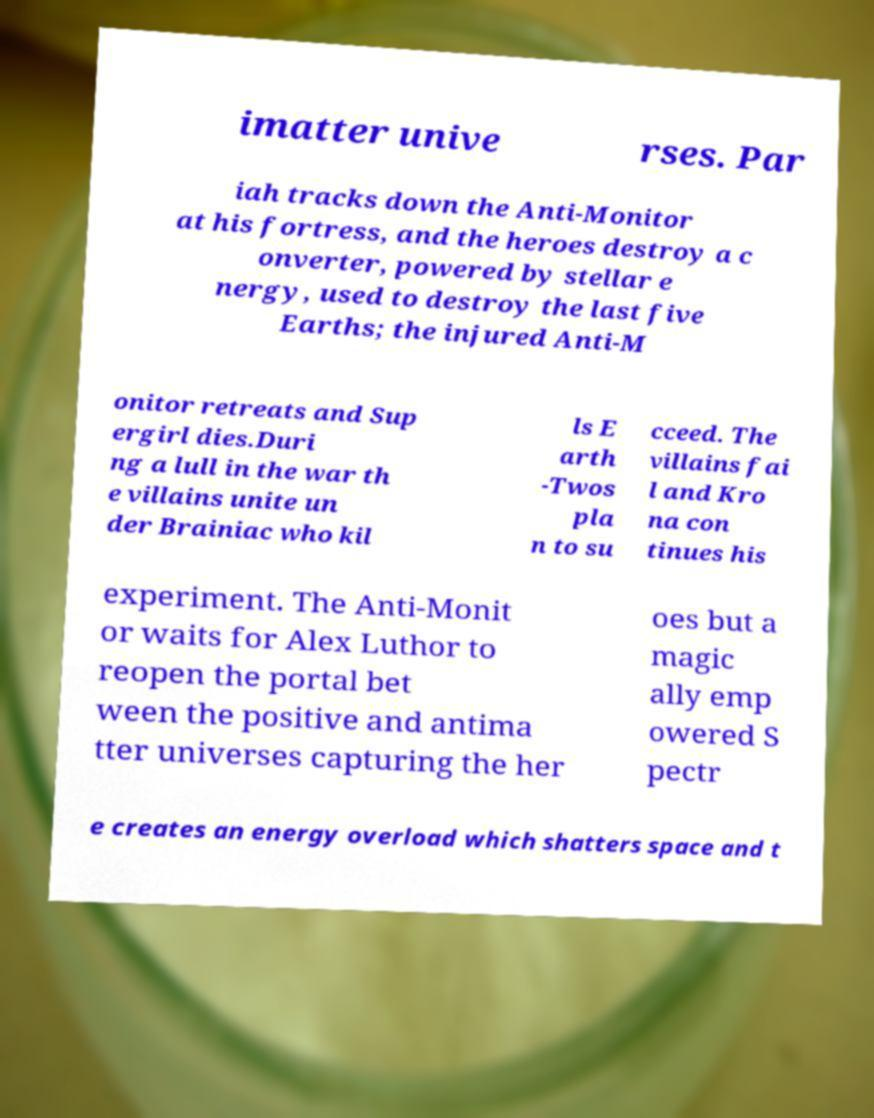Please identify and transcribe the text found in this image. imatter unive rses. Par iah tracks down the Anti-Monitor at his fortress, and the heroes destroy a c onverter, powered by stellar e nergy, used to destroy the last five Earths; the injured Anti-M onitor retreats and Sup ergirl dies.Duri ng a lull in the war th e villains unite un der Brainiac who kil ls E arth -Twos pla n to su cceed. The villains fai l and Kro na con tinues his experiment. The Anti-Monit or waits for Alex Luthor to reopen the portal bet ween the positive and antima tter universes capturing the her oes but a magic ally emp owered S pectr e creates an energy overload which shatters space and t 